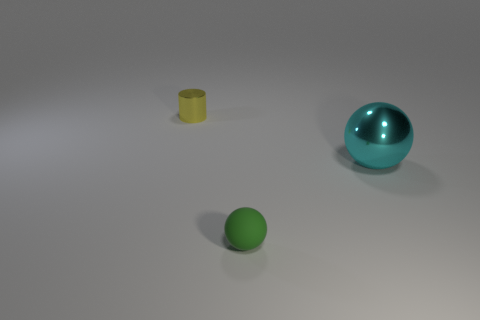There is a object that is behind the small green rubber sphere and on the left side of the large metallic thing; what color is it?
Offer a terse response. Yellow. Does the big cyan metallic object have the same shape as the green rubber thing?
Make the answer very short. Yes. There is a shiny object that is right of the tiny object that is to the left of the small matte object; what shape is it?
Provide a succinct answer. Sphere. Is the shape of the cyan shiny object the same as the metallic thing left of the green matte sphere?
Give a very brief answer. No. There is a cylinder that is the same size as the green rubber object; what is its color?
Offer a terse response. Yellow. Is the number of big objects behind the large cyan metal object less than the number of tiny things in front of the yellow cylinder?
Offer a very short reply. Yes. What is the shape of the metal thing that is on the left side of the small object that is on the right side of the metal object that is left of the small matte object?
Your answer should be very brief. Cylinder. How many metal objects are cyan balls or yellow cylinders?
Your answer should be compact. 2. What color is the sphere in front of the shiny thing that is in front of the tiny thing behind the green ball?
Ensure brevity in your answer.  Green. What color is the big metal thing that is the same shape as the tiny green rubber thing?
Your answer should be very brief. Cyan. 